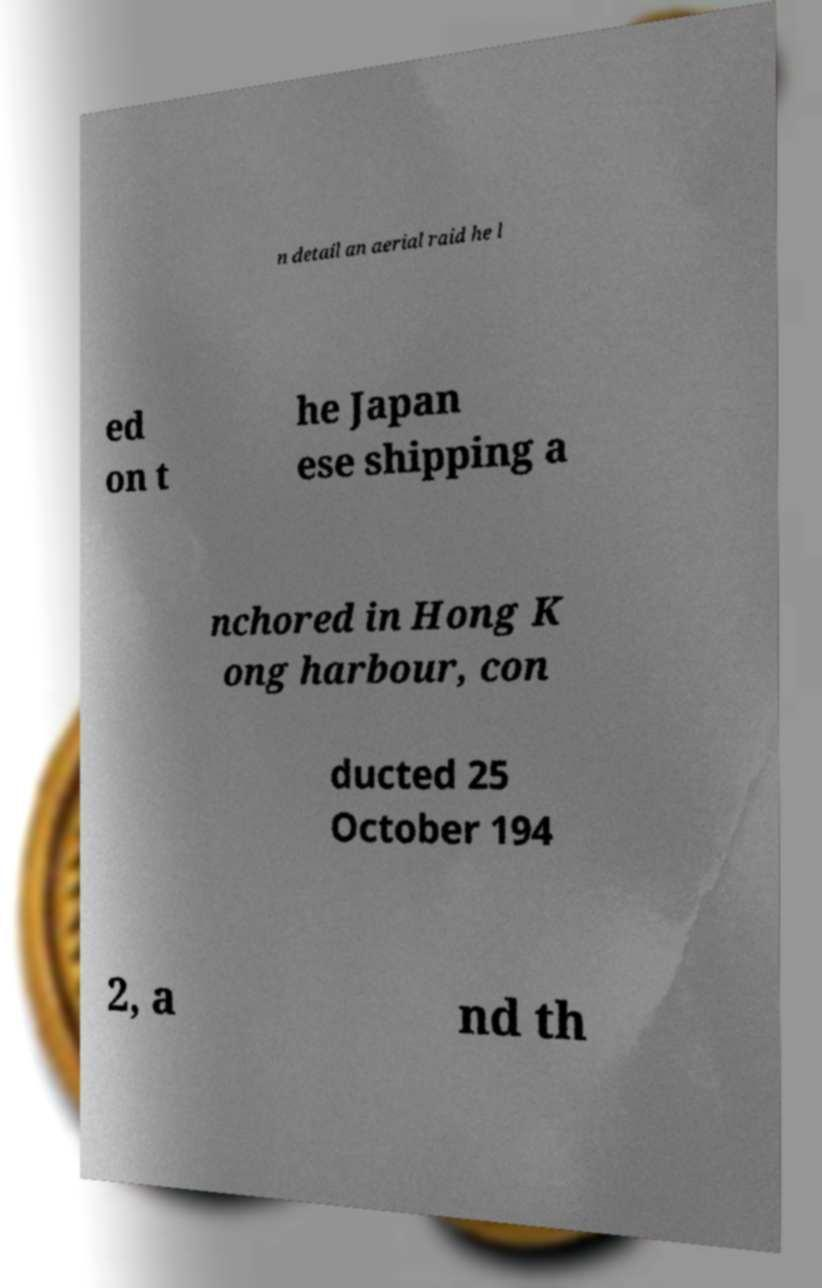There's text embedded in this image that I need extracted. Can you transcribe it verbatim? n detail an aerial raid he l ed on t he Japan ese shipping a nchored in Hong K ong harbour, con ducted 25 October 194 2, a nd th 